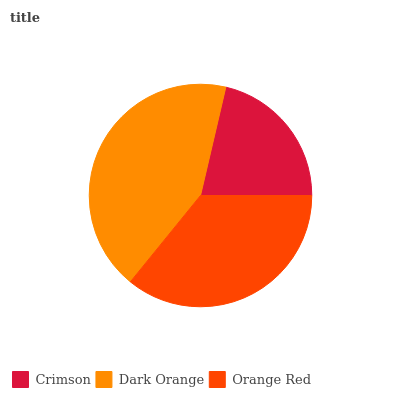Is Crimson the minimum?
Answer yes or no. Yes. Is Dark Orange the maximum?
Answer yes or no. Yes. Is Orange Red the minimum?
Answer yes or no. No. Is Orange Red the maximum?
Answer yes or no. No. Is Dark Orange greater than Orange Red?
Answer yes or no. Yes. Is Orange Red less than Dark Orange?
Answer yes or no. Yes. Is Orange Red greater than Dark Orange?
Answer yes or no. No. Is Dark Orange less than Orange Red?
Answer yes or no. No. Is Orange Red the high median?
Answer yes or no. Yes. Is Orange Red the low median?
Answer yes or no. Yes. Is Crimson the high median?
Answer yes or no. No. Is Dark Orange the low median?
Answer yes or no. No. 